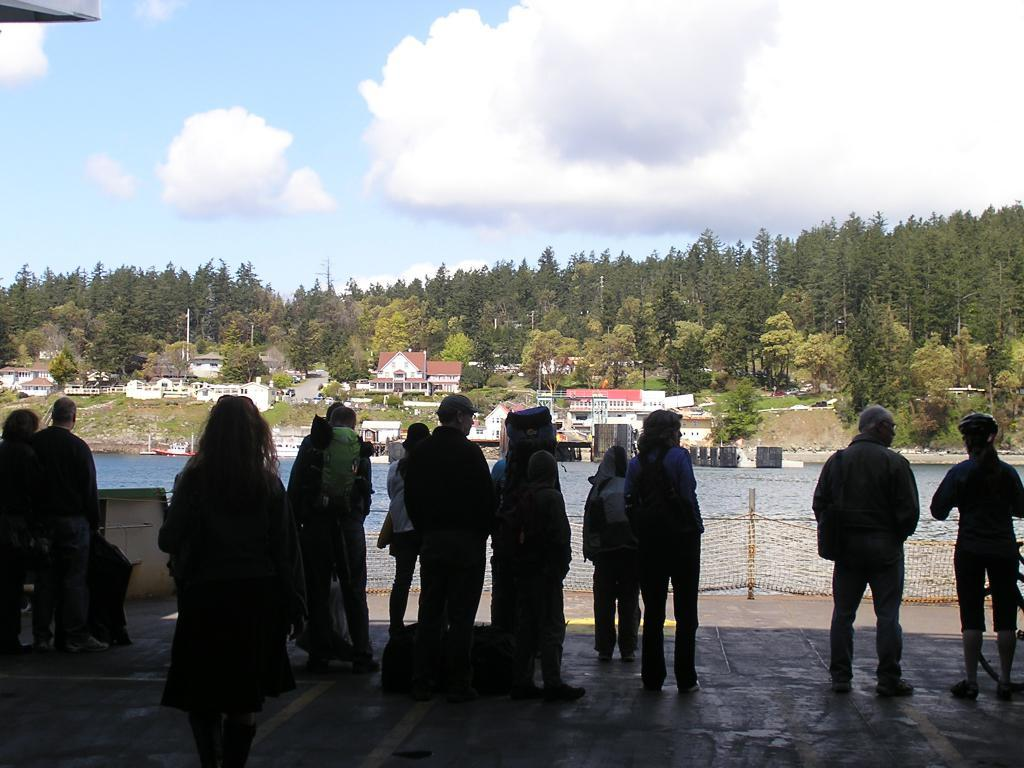What can be seen in the image? There are people standing in the image. What is in front of the people? There is a river in front of the people. What can be seen in the background of the image? There are buildings, trees, and the sky visible in the background of the image. How many pigs are sitting on the branch in the image? There are no pigs or branches present in the image. 